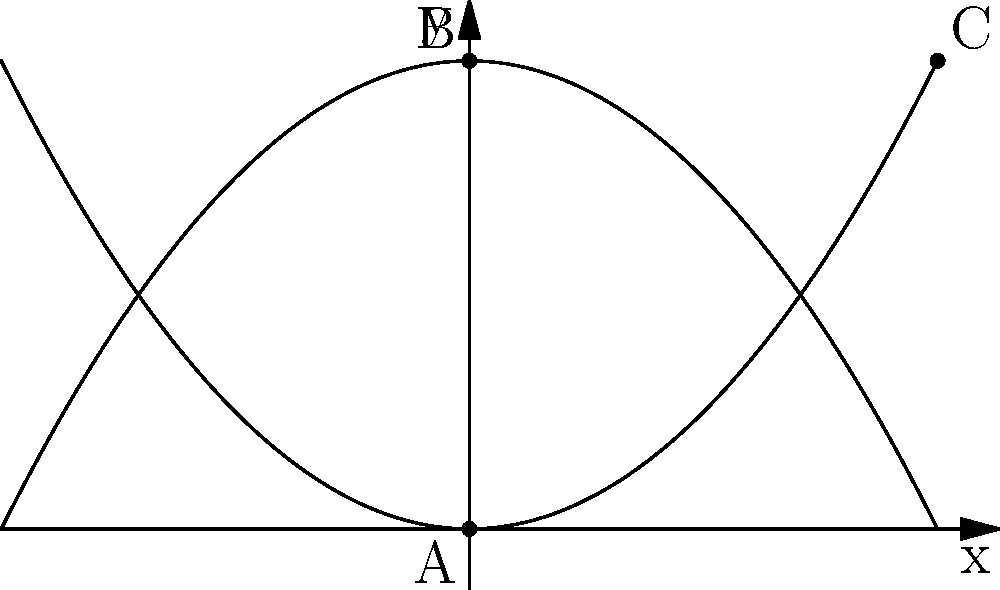In the diagram above, two parabolas are shown representing the spiritual journey of a soul through life. The lower parabola represents earthly experiences, while the upper inverted parabola symbolizes spiritual growth. Point A is the starting point of life, point B represents a spiritual awakening, and point C signifies the culmination of life's journey. If the equations of the lower and upper parabolas are $y = 0.25x^2$ and $y = -0.25x^2 + 4$ respectively, what is the x-coordinate of point C, symbolizing the completion of the soul's journey? To find the x-coordinate of point C, we need to follow these steps:

1) Point C is where the two parabolas intersect on the right side of the y-axis.

2) To find this intersection point, we need to set the equations equal to each other:

   $0.25x^2 = -0.25x^2 + 4$

3) Simplify by adding $0.25x^2$ to both sides:

   $0.5x^2 = 4$

4) Divide both sides by 0.5:

   $x^2 = 8$

5) Take the square root of both sides:

   $x = \pm \sqrt{8} = \pm 2\sqrt{2}$

6) Since we're looking for the positive x-coordinate (right side of y-axis), we take the positive value:

   $x = 2\sqrt{2}$

7) We can simplify this to a decimal:

   $x \approx 2.83$

This x-coordinate represents the point where the soul's earthly journey (lower parabola) meets its spiritual zenith (upper parabola), symbolizing the completion of life's journey.
Answer: $2\sqrt{2}$ or approximately 2.83 